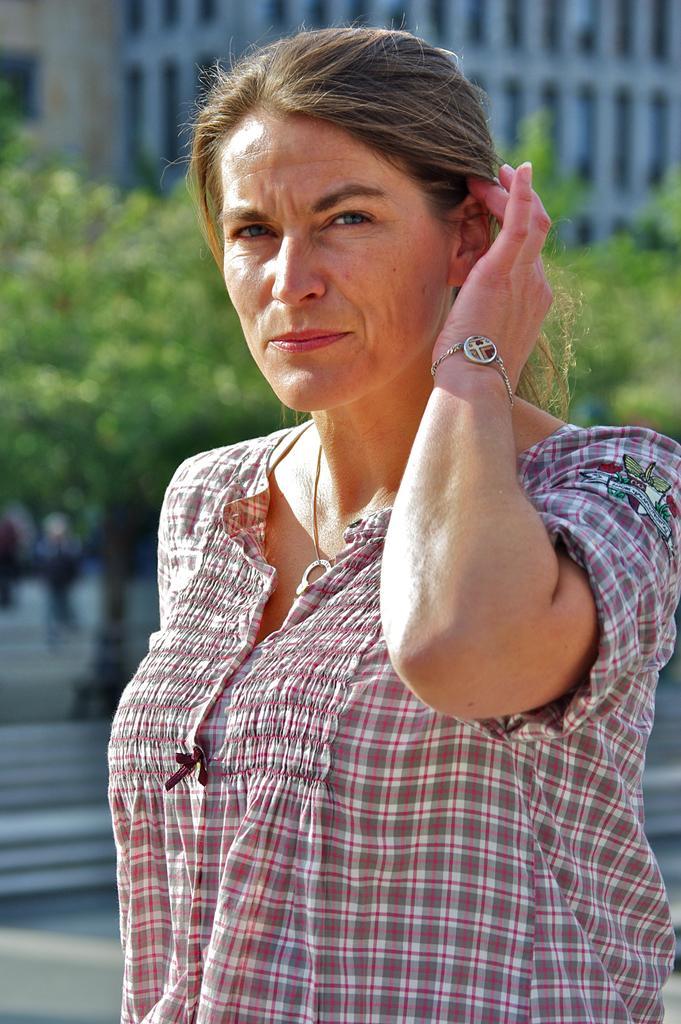In one or two sentences, can you explain what this image depicts? In the image there is a woman, she is posing for the photo and the background of the woman is blur. 